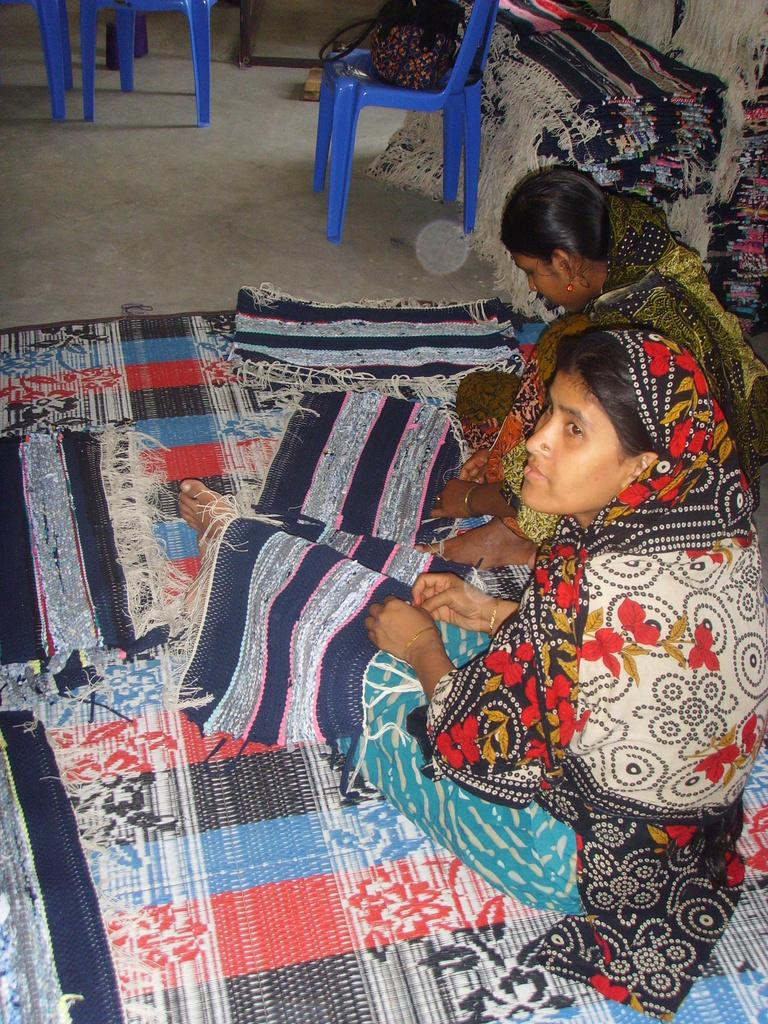What type of chair is in the image? There is a blue chair in the image. What is on the blue chair? There is a bag on the blue chair. What type of floor covering is present in the image? There are mats in the image. What is the woman in the image doing? A woman is sitting on a mat and holding a mat. Reasoning: Let's think step by the main subjects and objects in the image based on the provided facts. We then, we formulate questions that focus on the location and characteristics of these subjects and objects, ensuring that each question can be answered definitively with the information given. We avoid yes/no questions and ensure that the language is simple and clear. Absurd Question/Answer: How many shoes can be seen on the woman's feet in the image? There is: There is no information about shoes or the woman's feet in the image, so it cannot be determined. What type of question is the woman asking in the image? There is no indication of a question being asked in the image, as the woman is sitting on a mat and holding a mat. 